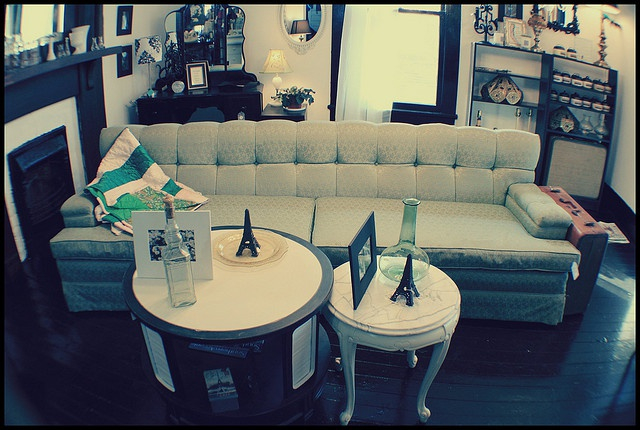Describe the objects in this image and their specific colors. I can see couch in black, tan, gray, darkblue, and blue tones, suitcase in black, gray, navy, and tan tones, bottle in black, darkgray, and gray tones, vase in black, darkgray, beige, and teal tones, and potted plant in black, tan, navy, and teal tones in this image. 